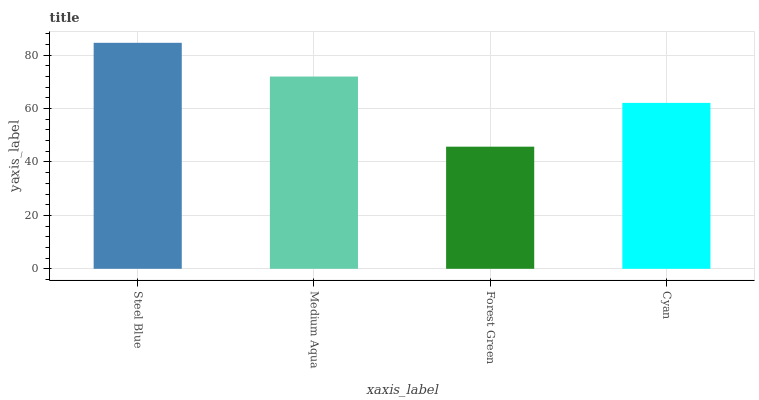Is Forest Green the minimum?
Answer yes or no. Yes. Is Steel Blue the maximum?
Answer yes or no. Yes. Is Medium Aqua the minimum?
Answer yes or no. No. Is Medium Aqua the maximum?
Answer yes or no. No. Is Steel Blue greater than Medium Aqua?
Answer yes or no. Yes. Is Medium Aqua less than Steel Blue?
Answer yes or no. Yes. Is Medium Aqua greater than Steel Blue?
Answer yes or no. No. Is Steel Blue less than Medium Aqua?
Answer yes or no. No. Is Medium Aqua the high median?
Answer yes or no. Yes. Is Cyan the low median?
Answer yes or no. Yes. Is Steel Blue the high median?
Answer yes or no. No. Is Medium Aqua the low median?
Answer yes or no. No. 